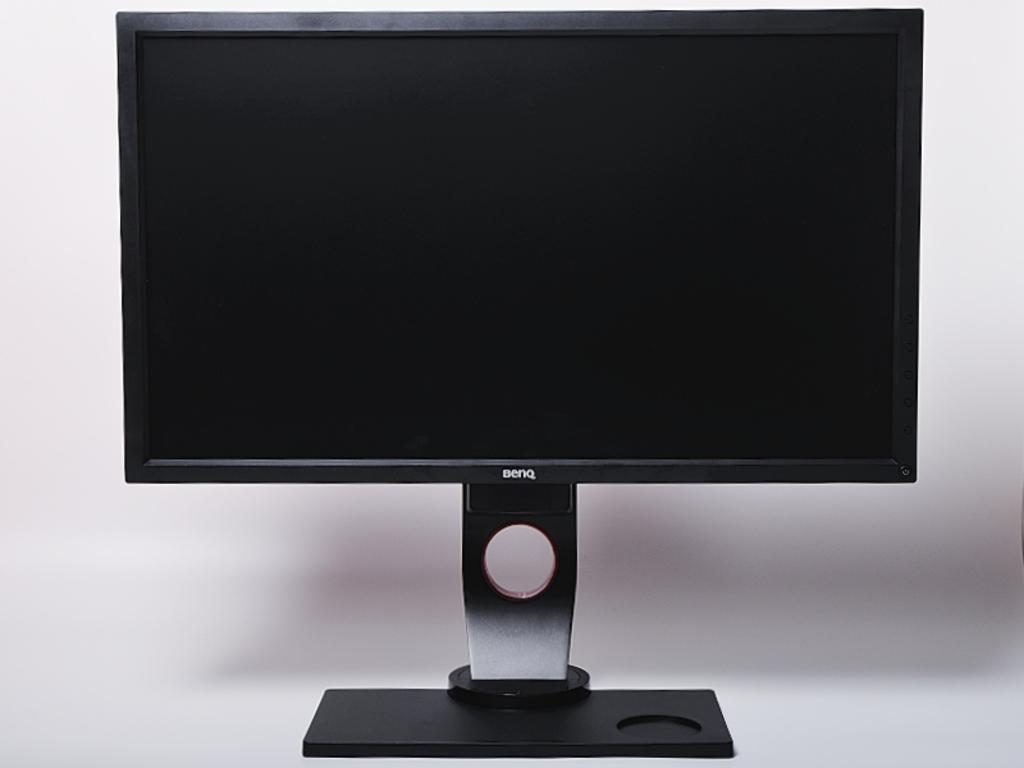<image>
Provide a brief description of the given image. a screen with Benq on the bottom of it 